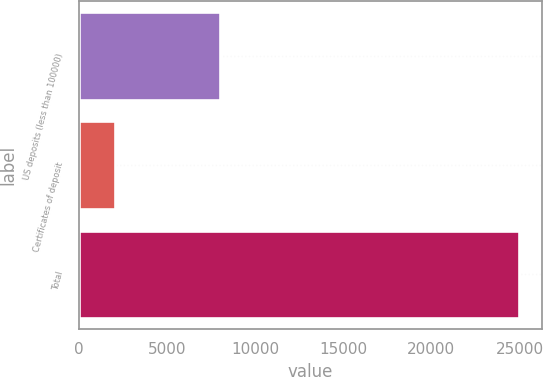<chart> <loc_0><loc_0><loc_500><loc_500><bar_chart><fcel>US deposits (less than 100000)<fcel>Certificates of deposit<fcel>Total<nl><fcel>8001<fcel>2059<fcel>24994<nl></chart> 